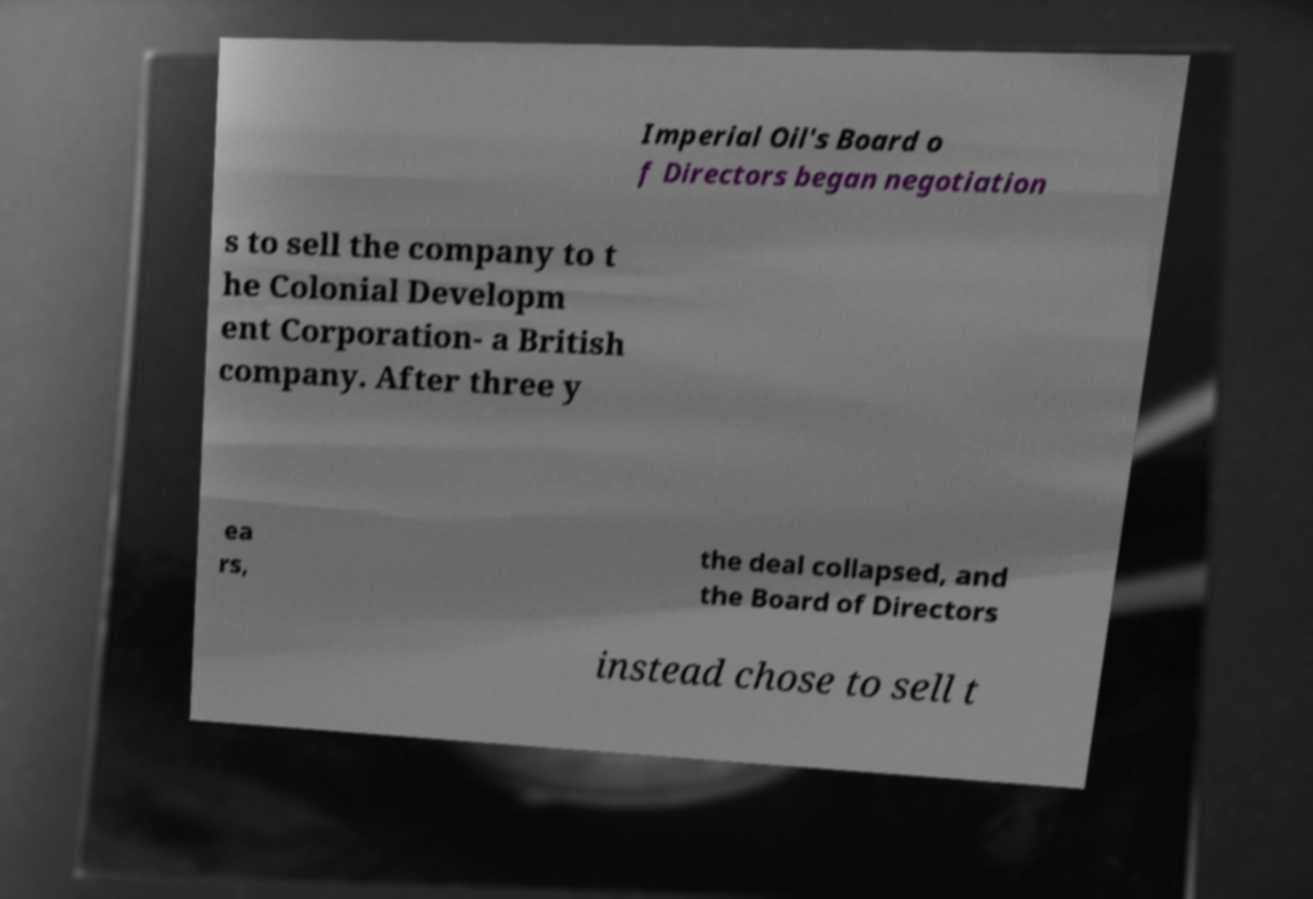Can you read and provide the text displayed in the image?This photo seems to have some interesting text. Can you extract and type it out for me? Imperial Oil's Board o f Directors began negotiation s to sell the company to t he Colonial Developm ent Corporation- a British company. After three y ea rs, the deal collapsed, and the Board of Directors instead chose to sell t 